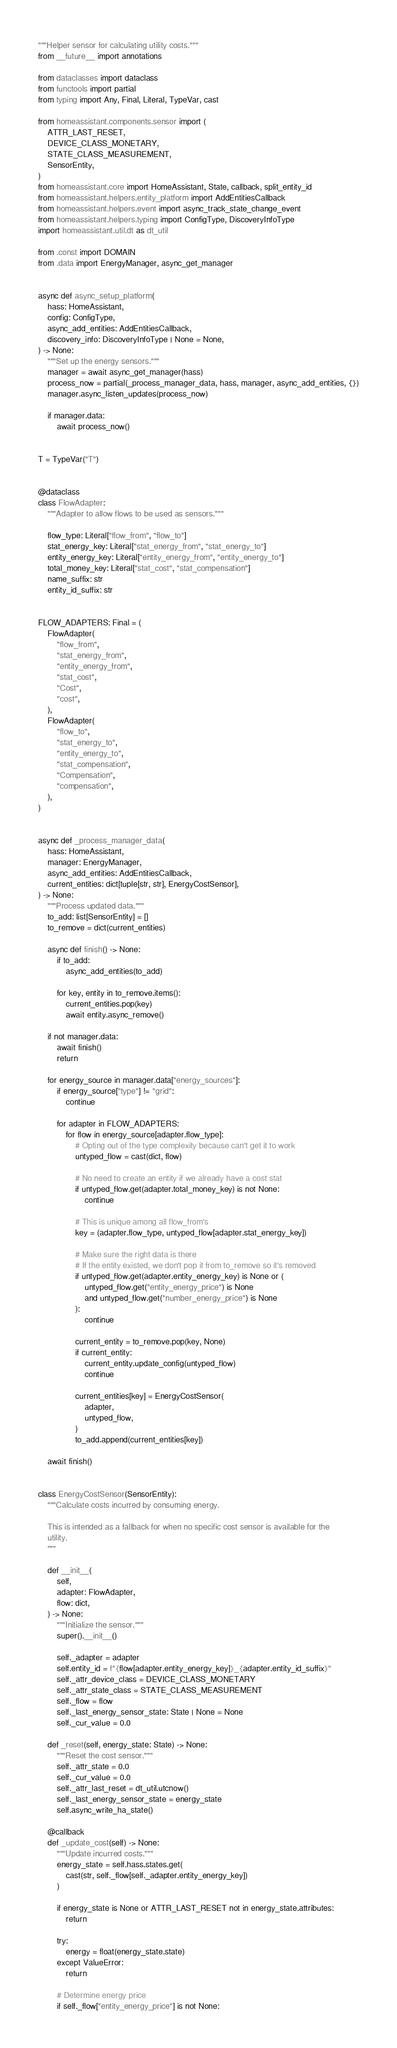<code> <loc_0><loc_0><loc_500><loc_500><_Python_>"""Helper sensor for calculating utility costs."""
from __future__ import annotations

from dataclasses import dataclass
from functools import partial
from typing import Any, Final, Literal, TypeVar, cast

from homeassistant.components.sensor import (
    ATTR_LAST_RESET,
    DEVICE_CLASS_MONETARY,
    STATE_CLASS_MEASUREMENT,
    SensorEntity,
)
from homeassistant.core import HomeAssistant, State, callback, split_entity_id
from homeassistant.helpers.entity_platform import AddEntitiesCallback
from homeassistant.helpers.event import async_track_state_change_event
from homeassistant.helpers.typing import ConfigType, DiscoveryInfoType
import homeassistant.util.dt as dt_util

from .const import DOMAIN
from .data import EnergyManager, async_get_manager


async def async_setup_platform(
    hass: HomeAssistant,
    config: ConfigType,
    async_add_entities: AddEntitiesCallback,
    discovery_info: DiscoveryInfoType | None = None,
) -> None:
    """Set up the energy sensors."""
    manager = await async_get_manager(hass)
    process_now = partial(_process_manager_data, hass, manager, async_add_entities, {})
    manager.async_listen_updates(process_now)

    if manager.data:
        await process_now()


T = TypeVar("T")


@dataclass
class FlowAdapter:
    """Adapter to allow flows to be used as sensors."""

    flow_type: Literal["flow_from", "flow_to"]
    stat_energy_key: Literal["stat_energy_from", "stat_energy_to"]
    entity_energy_key: Literal["entity_energy_from", "entity_energy_to"]
    total_money_key: Literal["stat_cost", "stat_compensation"]
    name_suffix: str
    entity_id_suffix: str


FLOW_ADAPTERS: Final = (
    FlowAdapter(
        "flow_from",
        "stat_energy_from",
        "entity_energy_from",
        "stat_cost",
        "Cost",
        "cost",
    ),
    FlowAdapter(
        "flow_to",
        "stat_energy_to",
        "entity_energy_to",
        "stat_compensation",
        "Compensation",
        "compensation",
    ),
)


async def _process_manager_data(
    hass: HomeAssistant,
    manager: EnergyManager,
    async_add_entities: AddEntitiesCallback,
    current_entities: dict[tuple[str, str], EnergyCostSensor],
) -> None:
    """Process updated data."""
    to_add: list[SensorEntity] = []
    to_remove = dict(current_entities)

    async def finish() -> None:
        if to_add:
            async_add_entities(to_add)

        for key, entity in to_remove.items():
            current_entities.pop(key)
            await entity.async_remove()

    if not manager.data:
        await finish()
        return

    for energy_source in manager.data["energy_sources"]:
        if energy_source["type"] != "grid":
            continue

        for adapter in FLOW_ADAPTERS:
            for flow in energy_source[adapter.flow_type]:
                # Opting out of the type complexity because can't get it to work
                untyped_flow = cast(dict, flow)

                # No need to create an entity if we already have a cost stat
                if untyped_flow.get(adapter.total_money_key) is not None:
                    continue

                # This is unique among all flow_from's
                key = (adapter.flow_type, untyped_flow[adapter.stat_energy_key])

                # Make sure the right data is there
                # If the entity existed, we don't pop it from to_remove so it's removed
                if untyped_flow.get(adapter.entity_energy_key) is None or (
                    untyped_flow.get("entity_energy_price") is None
                    and untyped_flow.get("number_energy_price") is None
                ):
                    continue

                current_entity = to_remove.pop(key, None)
                if current_entity:
                    current_entity.update_config(untyped_flow)
                    continue

                current_entities[key] = EnergyCostSensor(
                    adapter,
                    untyped_flow,
                )
                to_add.append(current_entities[key])

    await finish()


class EnergyCostSensor(SensorEntity):
    """Calculate costs incurred by consuming energy.

    This is intended as a fallback for when no specific cost sensor is available for the
    utility.
    """

    def __init__(
        self,
        adapter: FlowAdapter,
        flow: dict,
    ) -> None:
        """Initialize the sensor."""
        super().__init__()

        self._adapter = adapter
        self.entity_id = f"{flow[adapter.entity_energy_key]}_{adapter.entity_id_suffix}"
        self._attr_device_class = DEVICE_CLASS_MONETARY
        self._attr_state_class = STATE_CLASS_MEASUREMENT
        self._flow = flow
        self._last_energy_sensor_state: State | None = None
        self._cur_value = 0.0

    def _reset(self, energy_state: State) -> None:
        """Reset the cost sensor."""
        self._attr_state = 0.0
        self._cur_value = 0.0
        self._attr_last_reset = dt_util.utcnow()
        self._last_energy_sensor_state = energy_state
        self.async_write_ha_state()

    @callback
    def _update_cost(self) -> None:
        """Update incurred costs."""
        energy_state = self.hass.states.get(
            cast(str, self._flow[self._adapter.entity_energy_key])
        )

        if energy_state is None or ATTR_LAST_RESET not in energy_state.attributes:
            return

        try:
            energy = float(energy_state.state)
        except ValueError:
            return

        # Determine energy price
        if self._flow["entity_energy_price"] is not None:</code> 